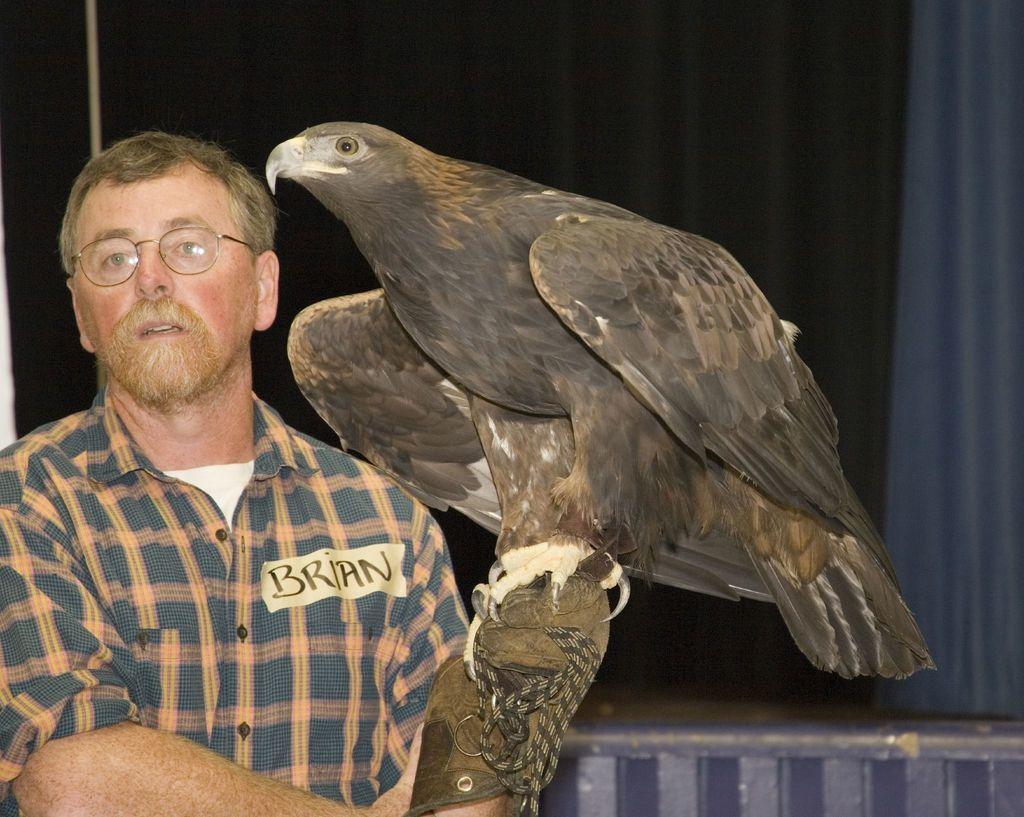Could you give a brief overview of what you see in this image? In this picture we can see an eagle sitting on the hand of a person. 